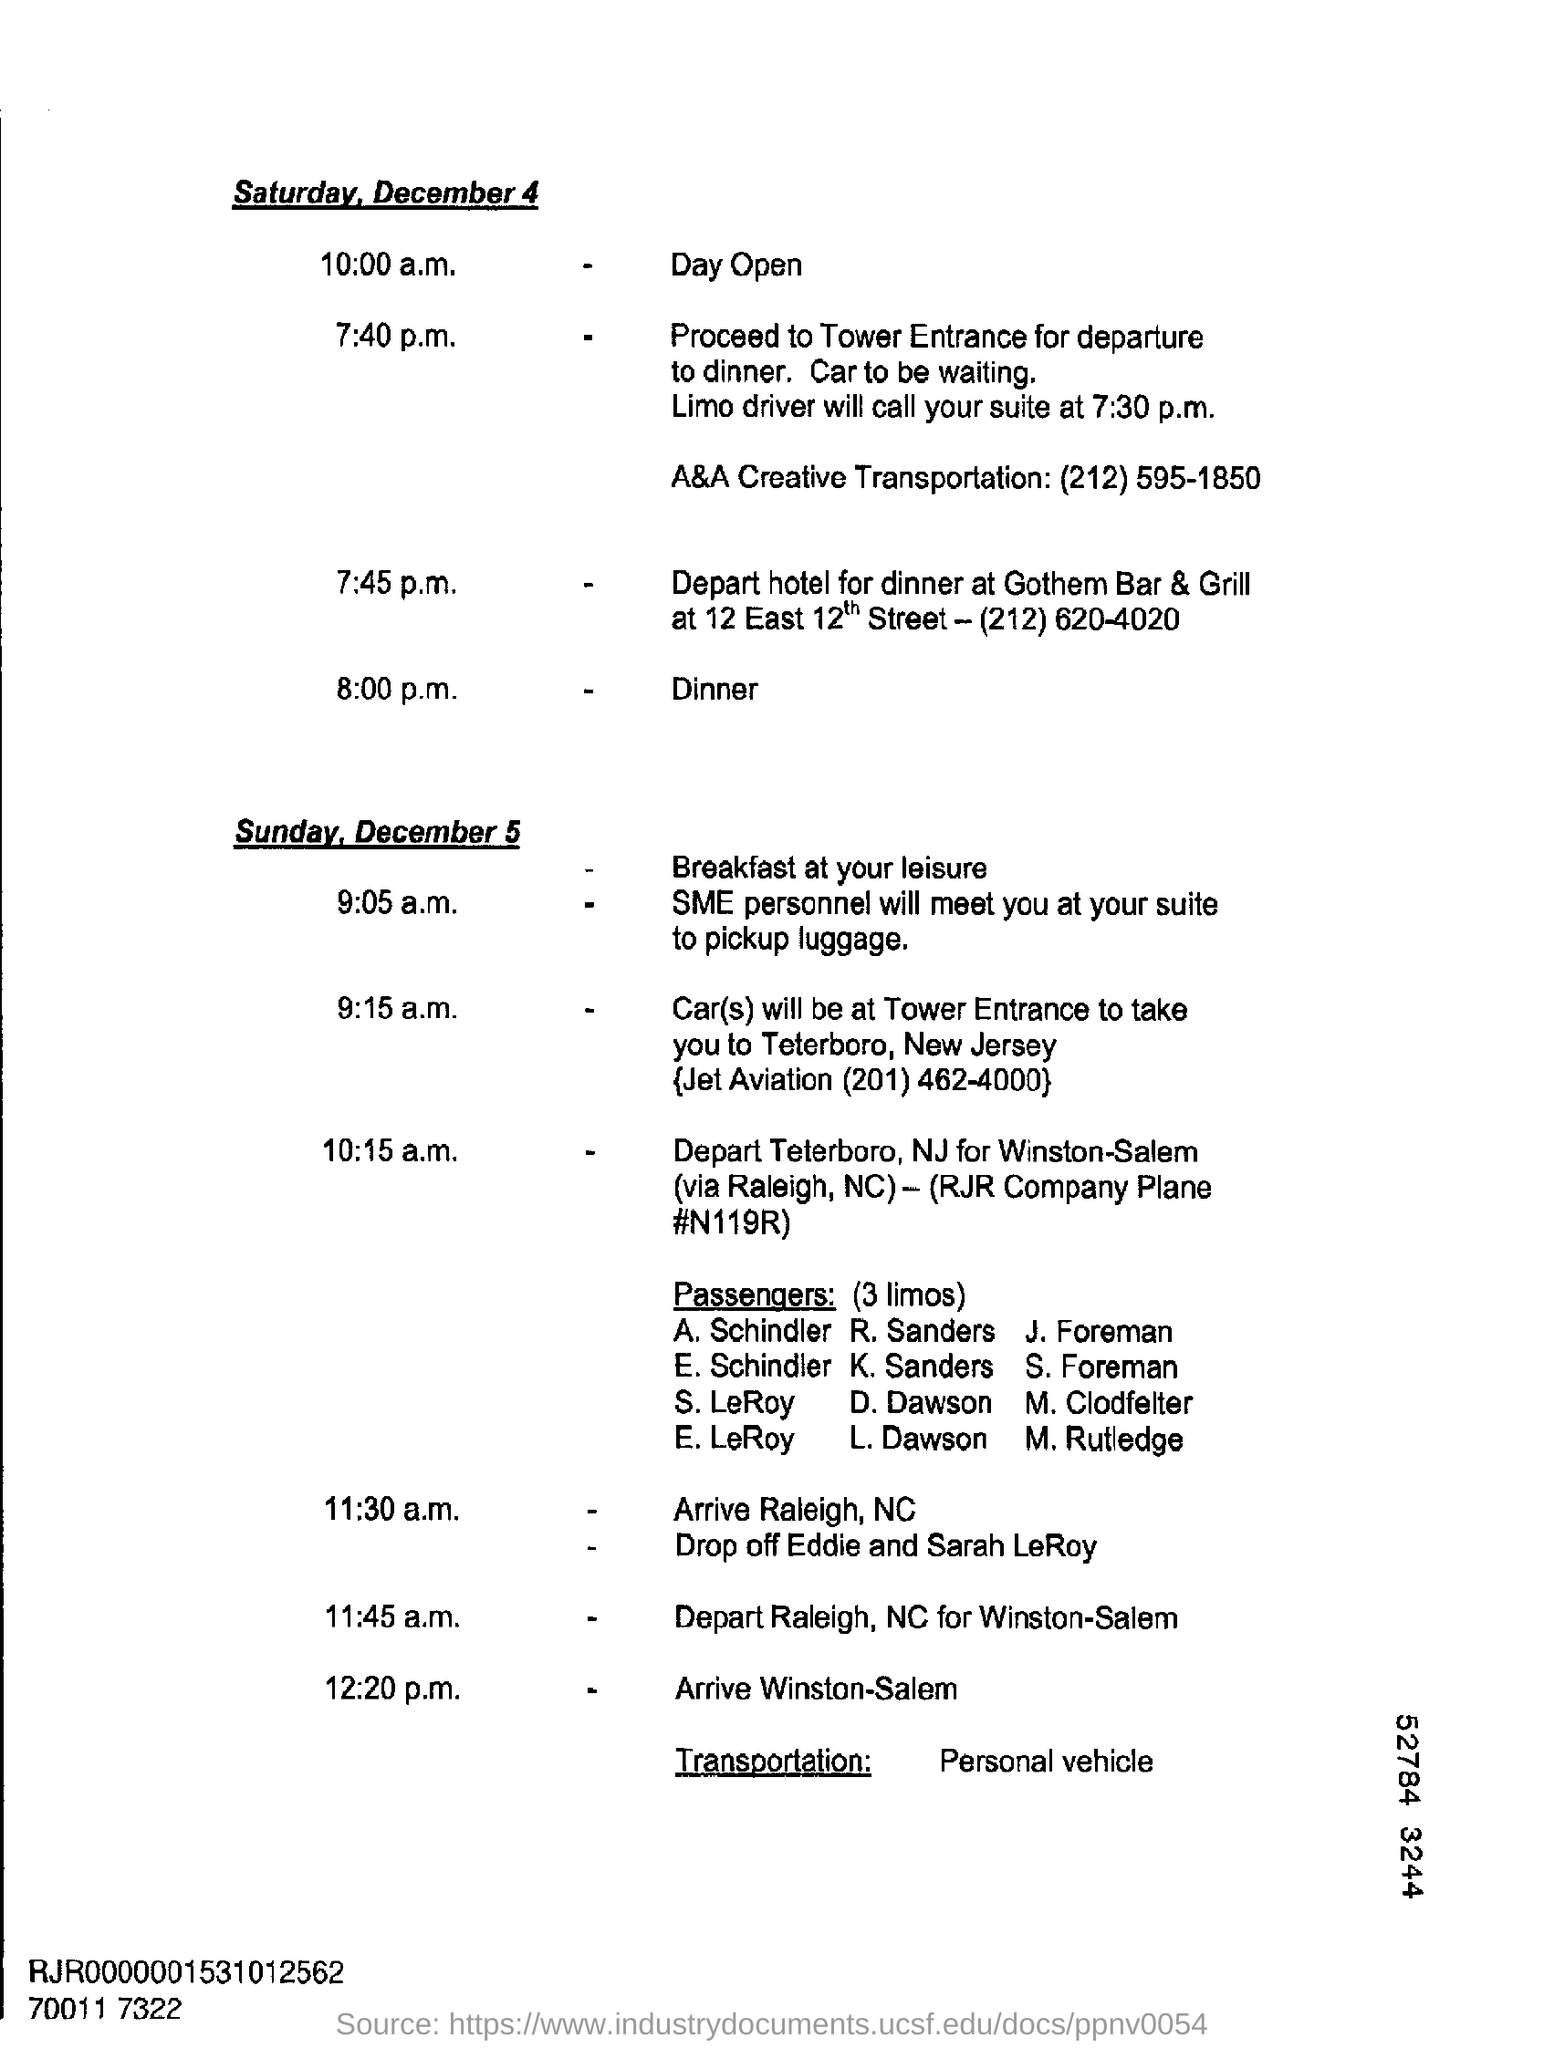Identify some key points in this picture. The time mentioned in the document for Open Day is 10:00 a.m. 